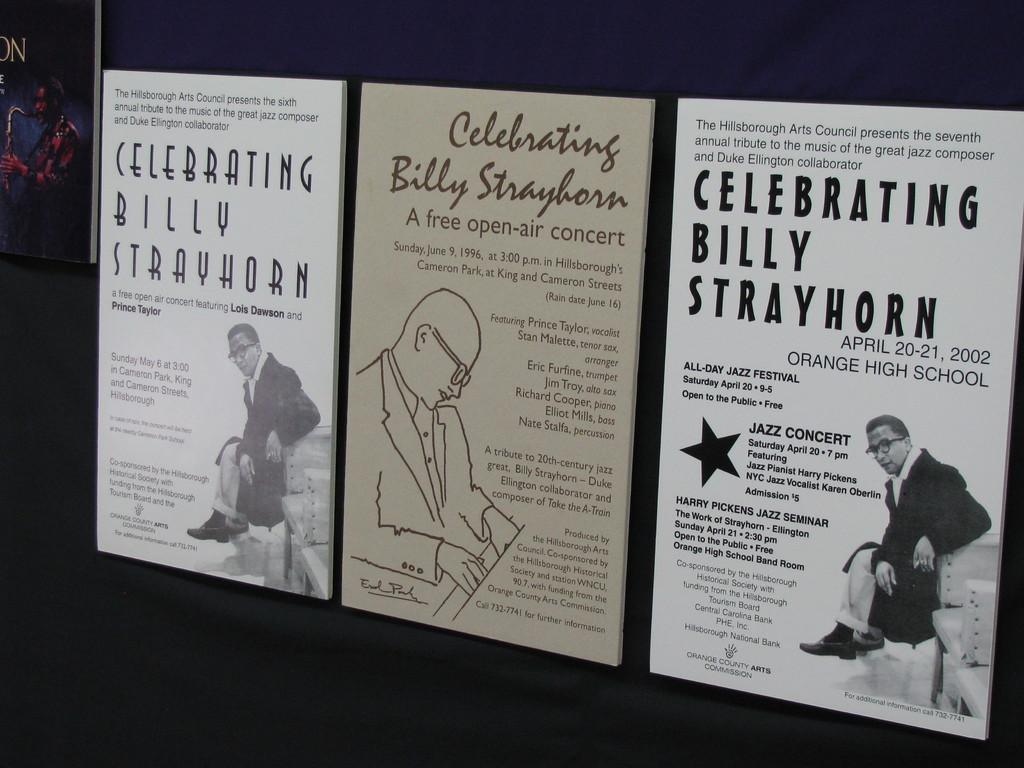<image>
Give a short and clear explanation of the subsequent image. One of the celebrations of Billy Strayhorn took place on April 20-21, 2002 at Orange High School. 